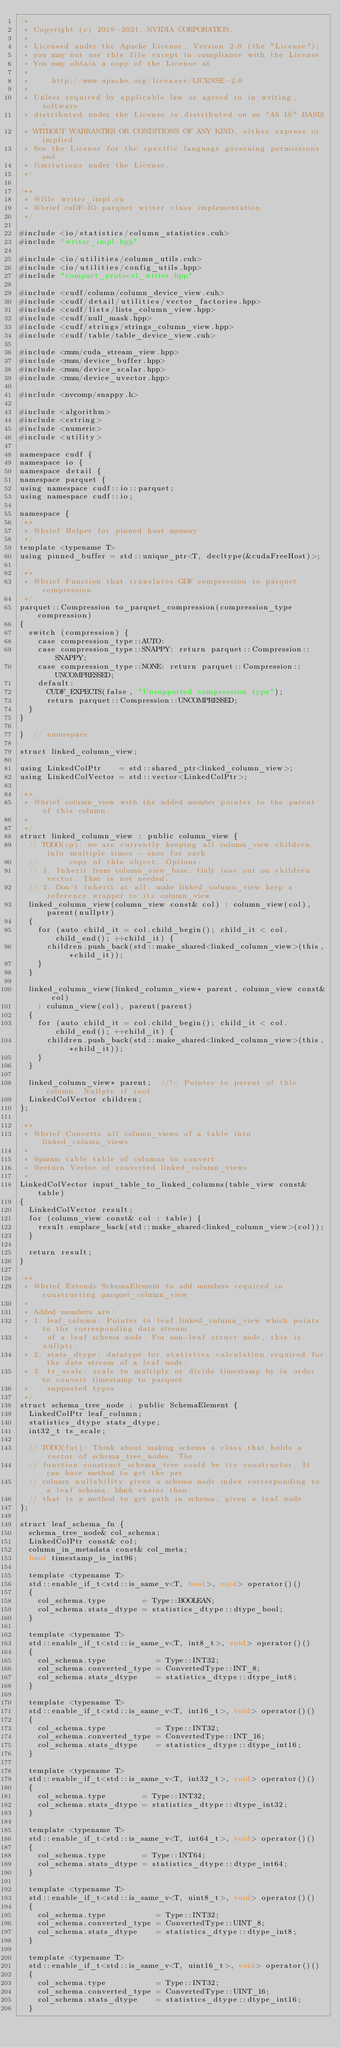Convert code to text. <code><loc_0><loc_0><loc_500><loc_500><_Cuda_>/*
 * Copyright (c) 2019-2021, NVIDIA CORPORATION.
 *
 * Licensed under the Apache License, Version 2.0 (the "License");
 * you may not use this file except in compliance with the License.
 * You may obtain a copy of the License at
 *
 *     http://www.apache.org/licenses/LICENSE-2.0
 *
 * Unless required by applicable law or agreed to in writing, software
 * distributed under the License is distributed on an "AS IS" BASIS,
 * WITHOUT WARRANTIES OR CONDITIONS OF ANY KIND, either express or implied.
 * See the License for the specific language governing permissions and
 * limitations under the License.
 */

/**
 * @file writer_impl.cu
 * @brief cuDF-IO parquet writer class implementation
 */

#include <io/statistics/column_statistics.cuh>
#include "writer_impl.hpp"

#include <io/utilities/column_utils.cuh>
#include <io/utilities/config_utils.hpp>
#include "compact_protocol_writer.hpp"

#include <cudf/column/column_device_view.cuh>
#include <cudf/detail/utilities/vector_factories.hpp>
#include <cudf/lists/lists_column_view.hpp>
#include <cudf/null_mask.hpp>
#include <cudf/strings/strings_column_view.hpp>
#include <cudf/table/table_device_view.cuh>

#include <rmm/cuda_stream_view.hpp>
#include <rmm/device_buffer.hpp>
#include <rmm/device_scalar.hpp>
#include <rmm/device_uvector.hpp>

#include <nvcomp/snappy.h>

#include <algorithm>
#include <cstring>
#include <numeric>
#include <utility>

namespace cudf {
namespace io {
namespace detail {
namespace parquet {
using namespace cudf::io::parquet;
using namespace cudf::io;

namespace {
/**
 * @brief Helper for pinned host memory
 */
template <typename T>
using pinned_buffer = std::unique_ptr<T, decltype(&cudaFreeHost)>;

/**
 * @brief Function that translates GDF compression to parquet compression
 */
parquet::Compression to_parquet_compression(compression_type compression)
{
  switch (compression) {
    case compression_type::AUTO:
    case compression_type::SNAPPY: return parquet::Compression::SNAPPY;
    case compression_type::NONE: return parquet::Compression::UNCOMPRESSED;
    default:
      CUDF_EXPECTS(false, "Unsupported compression type");
      return parquet::Compression::UNCOMPRESSED;
  }
}

}  // namespace

struct linked_column_view;

using LinkedColPtr    = std::shared_ptr<linked_column_view>;
using LinkedColVector = std::vector<LinkedColPtr>;

/**
 * @brief column_view with the added member pointer to the parent of this column.
 *
 */
struct linked_column_view : public column_view {
  // TODO(cp): we are currently keeping all column_view children info multiple times - once for each
  //       copy of this object. Options:
  // 1. Inherit from column_view_base. Only lose out on children vector. That is not needed.
  // 2. Don't inherit at all. make linked_column_view keep a reference wrapper to its column_view
  linked_column_view(column_view const& col) : column_view(col), parent(nullptr)
  {
    for (auto child_it = col.child_begin(); child_it < col.child_end(); ++child_it) {
      children.push_back(std::make_shared<linked_column_view>(this, *child_it));
    }
  }

  linked_column_view(linked_column_view* parent, column_view const& col)
    : column_view(col), parent(parent)
  {
    for (auto child_it = col.child_begin(); child_it < col.child_end(); ++child_it) {
      children.push_back(std::make_shared<linked_column_view>(this, *child_it));
    }
  }

  linked_column_view* parent;  //!< Pointer to parent of this column. Nullptr if root
  LinkedColVector children;
};

/**
 * @brief Converts all column_views of a table into linked_column_views
 *
 * @param table table of columns to convert
 * @return Vector of converted linked_column_views
 */
LinkedColVector input_table_to_linked_columns(table_view const& table)
{
  LinkedColVector result;
  for (column_view const& col : table) {
    result.emplace_back(std::make_shared<linked_column_view>(col));
  }

  return result;
}

/**
 * @brief Extends SchemaElement to add members required in constructing parquet_column_view
 *
 * Added members are:
 * 1. leaf_column: Pointer to leaf linked_column_view which points to the corresponding data stream
 *    of a leaf schema node. For non-leaf struct node, this is nullptr.
 * 2. stats_dtype: datatype for statistics calculation required for the data stream of a leaf node.
 * 3. ts_scale: scale to multiply or divide timestamp by in order to convert timestamp to parquet
 *    supported types
 */
struct schema_tree_node : public SchemaElement {
  LinkedColPtr leaf_column;
  statistics_dtype stats_dtype;
  int32_t ts_scale;

  // TODO(fut): Think about making schema a class that holds a vector of schema_tree_nodes. The
  // function construct_schema_tree could be its constructor. It can have method to get the per
  // column nullability given a schema node index corresponding to a leaf schema. Much easier than
  // that is a method to get path in schema, given a leaf node
};

struct leaf_schema_fn {
  schema_tree_node& col_schema;
  LinkedColPtr const& col;
  column_in_metadata const& col_meta;
  bool timestamp_is_int96;

  template <typename T>
  std::enable_if_t<std::is_same_v<T, bool>, void> operator()()
  {
    col_schema.type        = Type::BOOLEAN;
    col_schema.stats_dtype = statistics_dtype::dtype_bool;
  }

  template <typename T>
  std::enable_if_t<std::is_same_v<T, int8_t>, void> operator()()
  {
    col_schema.type           = Type::INT32;
    col_schema.converted_type = ConvertedType::INT_8;
    col_schema.stats_dtype    = statistics_dtype::dtype_int8;
  }

  template <typename T>
  std::enable_if_t<std::is_same_v<T, int16_t>, void> operator()()
  {
    col_schema.type           = Type::INT32;
    col_schema.converted_type = ConvertedType::INT_16;
    col_schema.stats_dtype    = statistics_dtype::dtype_int16;
  }

  template <typename T>
  std::enable_if_t<std::is_same_v<T, int32_t>, void> operator()()
  {
    col_schema.type        = Type::INT32;
    col_schema.stats_dtype = statistics_dtype::dtype_int32;
  }

  template <typename T>
  std::enable_if_t<std::is_same_v<T, int64_t>, void> operator()()
  {
    col_schema.type        = Type::INT64;
    col_schema.stats_dtype = statistics_dtype::dtype_int64;
  }

  template <typename T>
  std::enable_if_t<std::is_same_v<T, uint8_t>, void> operator()()
  {
    col_schema.type           = Type::INT32;
    col_schema.converted_type = ConvertedType::UINT_8;
    col_schema.stats_dtype    = statistics_dtype::dtype_int8;
  }

  template <typename T>
  std::enable_if_t<std::is_same_v<T, uint16_t>, void> operator()()
  {
    col_schema.type           = Type::INT32;
    col_schema.converted_type = ConvertedType::UINT_16;
    col_schema.stats_dtype    = statistics_dtype::dtype_int16;
  }
</code> 